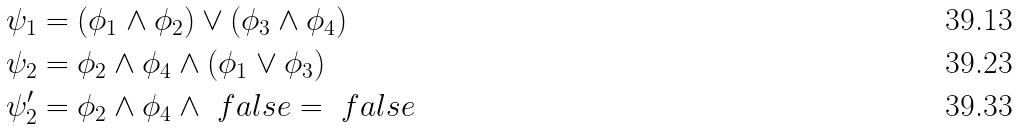Convert formula to latex. <formula><loc_0><loc_0><loc_500><loc_500>\psi _ { 1 } & = ( \phi _ { 1 } \land \phi _ { 2 } ) \lor ( \phi _ { 3 } \land \phi _ { 4 } ) \\ \psi _ { 2 } & = \phi _ { 2 } \land \phi _ { 4 } \land ( \phi _ { 1 } \lor \phi _ { 3 } ) \\ \psi ^ { \prime } _ { 2 } & = \phi _ { 2 } \land \phi _ { 4 } \land \ f a l s e = \ f a l s e</formula> 